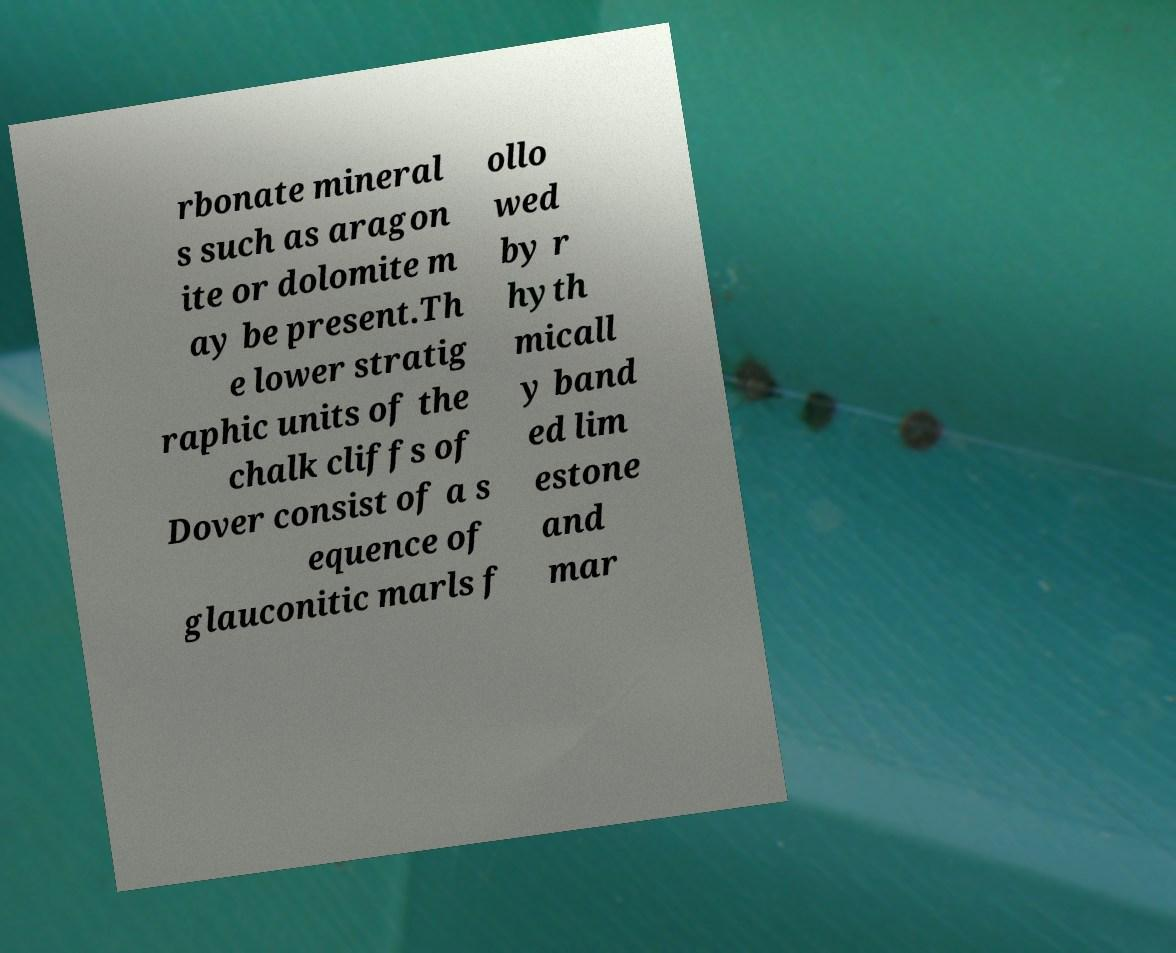What messages or text are displayed in this image? I need them in a readable, typed format. rbonate mineral s such as aragon ite or dolomite m ay be present.Th e lower stratig raphic units of the chalk cliffs of Dover consist of a s equence of glauconitic marls f ollo wed by r hyth micall y band ed lim estone and mar 